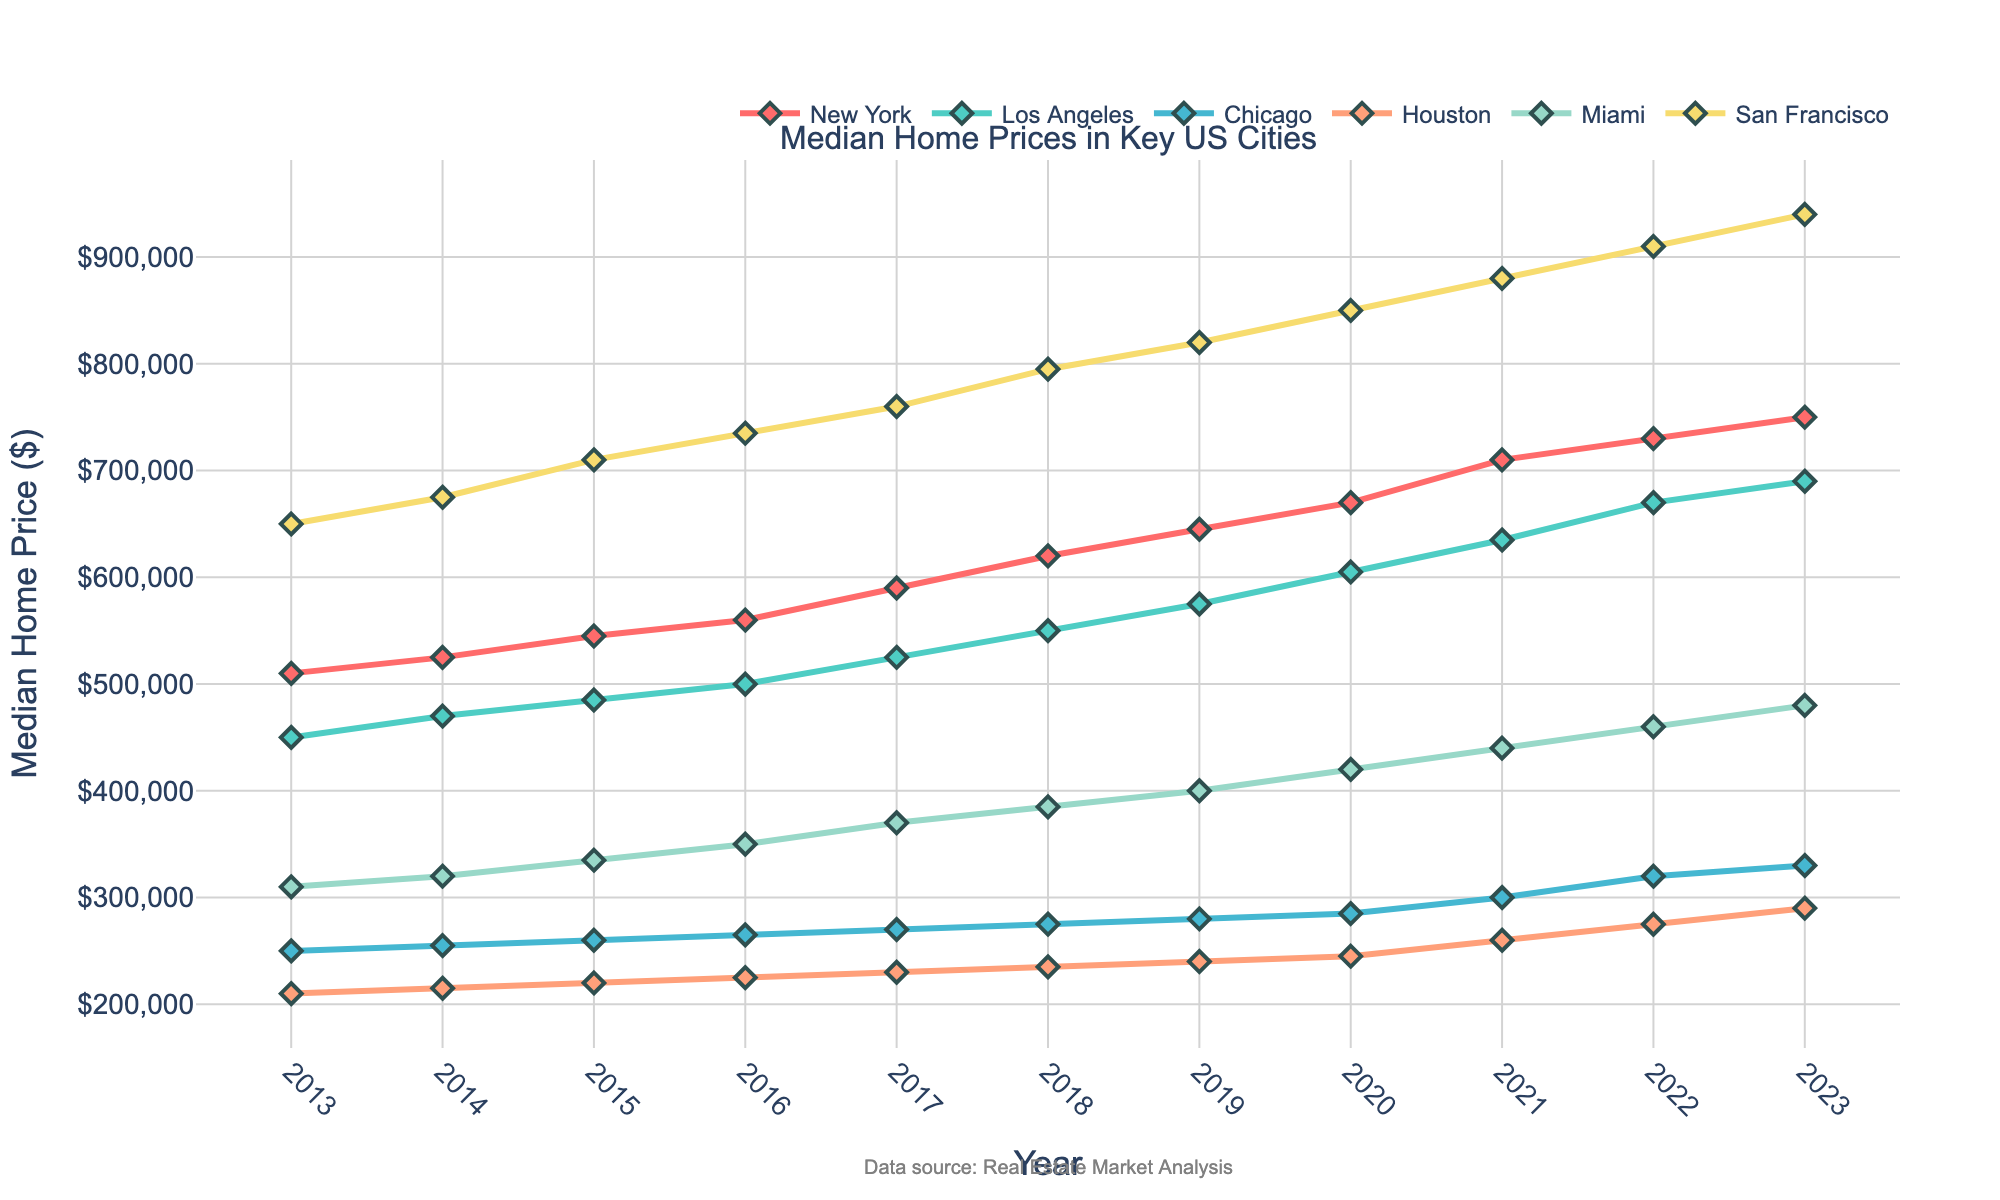What's the title of the figure? The title is usually placed at the top of the figure for easy identification. In this case, it is directly mentioned in the subplot title.
Answer: Median Home Prices in Key US Cities How many cities' data are represented in the plot? Count the lines or legend entries, each corresponding to a city.
Answer: 6 Which city had the highest median home price in 2023? Look at the data points for 2023 and identify the city with the highest y-value.
Answer: San Francisco In which year did New York surpass a median home price of $700,000? Identify the y-values that match or exceed $700,000 on the New York plot line and check the corresponding x-values.
Answer: 2021 What was the median home price in Miami in 2020? Locate the Miami plot line for the year 2020 and read off the y-axis value.
Answer: $420,000 Which city showed the highest growth in median home prices from 2013 to 2023? Calculate the difference between the 2023 and 2013 values for all cities, then compare these differences.
Answer: San Francisco By how much did the median home price in Chicago increase from 2013 to 2023? Subtract the 2013 value from the 2023 value for Chicago.
Answer: $80,000 Between Miami and Houston, which city had a larger median home price in 2017? Compare the y-values of Miami and Houston for the year 2017.
Answer: Miami What's the average median home price in New York over the decade? Sum all the New York values from 2013 to 2023 and divide by the number of years (11).
Answer: $611,818 Which city had the most stable median home prices over the past decade? Compare the fluctuations in the plot lines for each city and identify the one with the least variation.
Answer: Chicago 